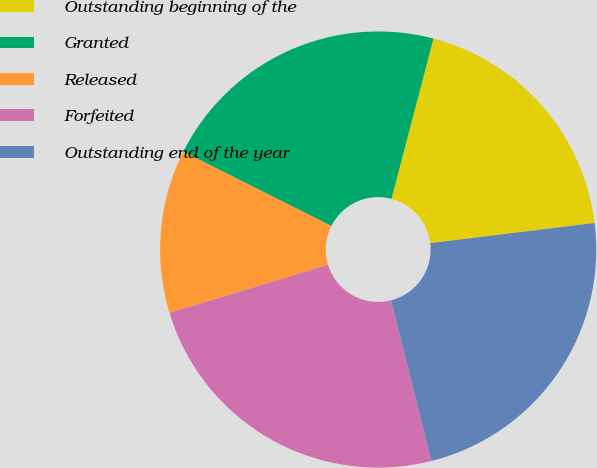Convert chart. <chart><loc_0><loc_0><loc_500><loc_500><pie_chart><fcel>Outstanding beginning of the<fcel>Granted<fcel>Released<fcel>Forfeited<fcel>Outstanding end of the year<nl><fcel>18.98%<fcel>21.68%<fcel>12.1%<fcel>24.23%<fcel>23.02%<nl></chart> 